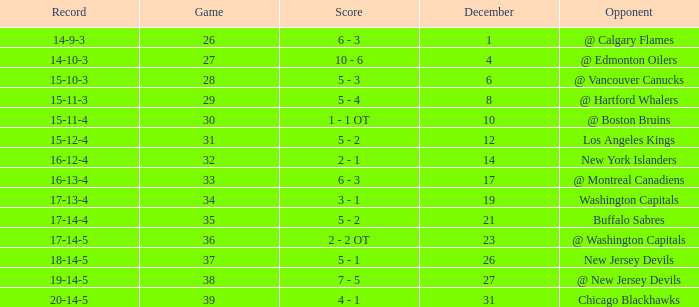Game larger than 34, and a December smaller than 23 had what record? 17-14-4. 